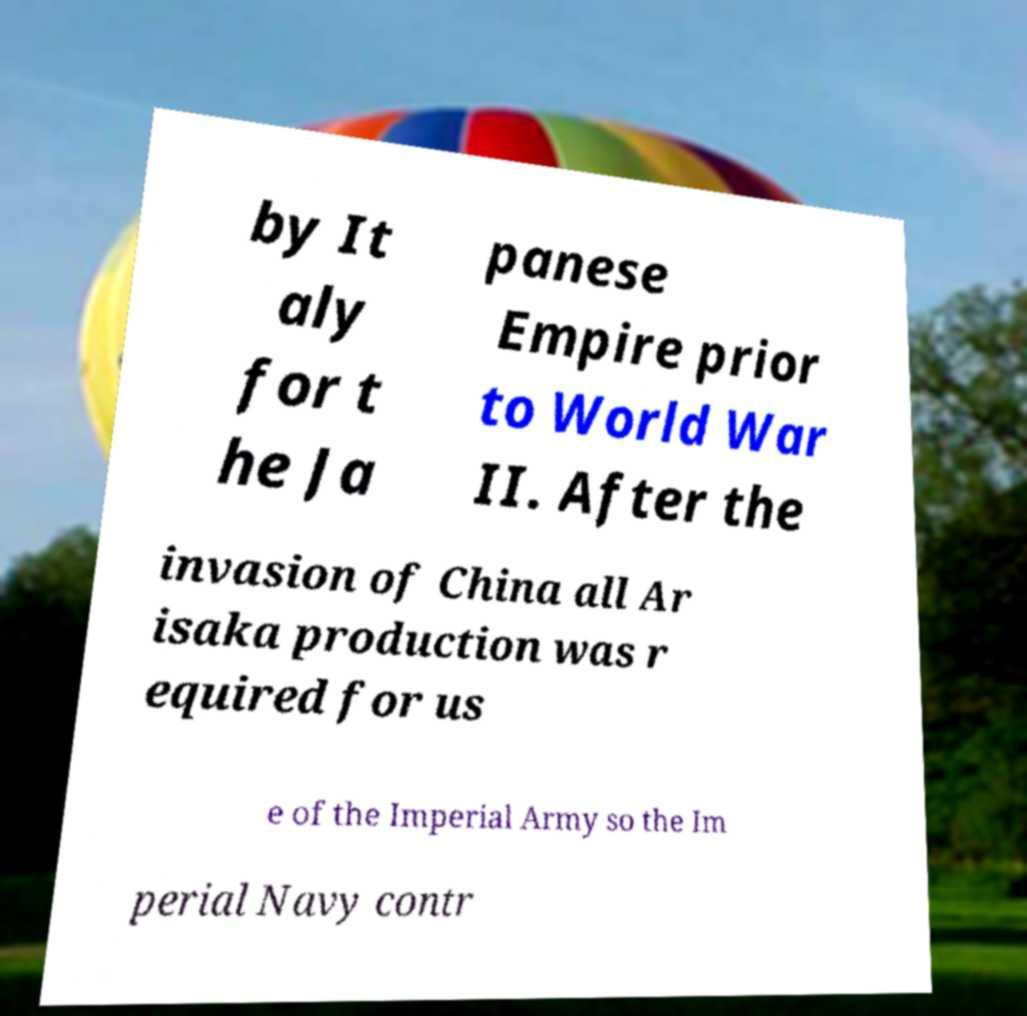Can you accurately transcribe the text from the provided image for me? by It aly for t he Ja panese Empire prior to World War II. After the invasion of China all Ar isaka production was r equired for us e of the Imperial Army so the Im perial Navy contr 